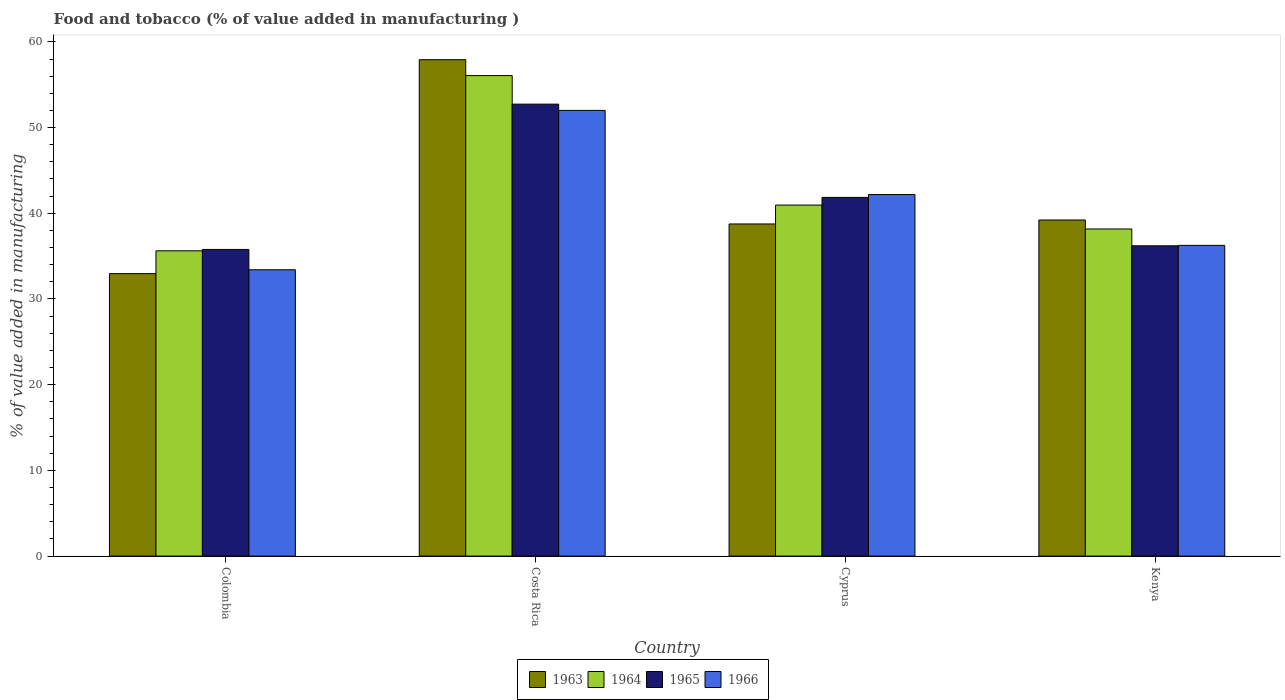Are the number of bars per tick equal to the number of legend labels?
Provide a short and direct response. Yes. How many bars are there on the 2nd tick from the left?
Ensure brevity in your answer.  4. How many bars are there on the 1st tick from the right?
Ensure brevity in your answer.  4. What is the label of the 3rd group of bars from the left?
Your response must be concise. Cyprus. What is the value added in manufacturing food and tobacco in 1966 in Cyprus?
Keep it short and to the point. 42.19. Across all countries, what is the maximum value added in manufacturing food and tobacco in 1965?
Offer a very short reply. 52.73. Across all countries, what is the minimum value added in manufacturing food and tobacco in 1964?
Make the answer very short. 35.62. In which country was the value added in manufacturing food and tobacco in 1965 minimum?
Offer a very short reply. Colombia. What is the total value added in manufacturing food and tobacco in 1965 in the graph?
Your response must be concise. 166.57. What is the difference between the value added in manufacturing food and tobacco in 1963 in Costa Rica and that in Kenya?
Your response must be concise. 18.7. What is the difference between the value added in manufacturing food and tobacco in 1966 in Costa Rica and the value added in manufacturing food and tobacco in 1964 in Colombia?
Ensure brevity in your answer.  16.38. What is the average value added in manufacturing food and tobacco in 1964 per country?
Offer a very short reply. 42.7. What is the difference between the value added in manufacturing food and tobacco of/in 1966 and value added in manufacturing food and tobacco of/in 1963 in Kenya?
Provide a short and direct response. -2.96. What is the ratio of the value added in manufacturing food and tobacco in 1965 in Costa Rica to that in Kenya?
Your response must be concise. 1.46. Is the value added in manufacturing food and tobacco in 1963 in Costa Rica less than that in Cyprus?
Provide a succinct answer. No. What is the difference between the highest and the second highest value added in manufacturing food and tobacco in 1966?
Provide a short and direct response. -9.82. What is the difference between the highest and the lowest value added in manufacturing food and tobacco in 1966?
Your answer should be compact. 18.59. In how many countries, is the value added in manufacturing food and tobacco in 1966 greater than the average value added in manufacturing food and tobacco in 1966 taken over all countries?
Your response must be concise. 2. Is the sum of the value added in manufacturing food and tobacco in 1964 in Colombia and Kenya greater than the maximum value added in manufacturing food and tobacco in 1965 across all countries?
Your response must be concise. Yes. Is it the case that in every country, the sum of the value added in manufacturing food and tobacco in 1966 and value added in manufacturing food and tobacco in 1964 is greater than the sum of value added in manufacturing food and tobacco in 1965 and value added in manufacturing food and tobacco in 1963?
Your answer should be very brief. No. What does the 3rd bar from the left in Cyprus represents?
Your answer should be compact. 1965. What does the 1st bar from the right in Costa Rica represents?
Your response must be concise. 1966. Is it the case that in every country, the sum of the value added in manufacturing food and tobacco in 1963 and value added in manufacturing food and tobacco in 1966 is greater than the value added in manufacturing food and tobacco in 1964?
Offer a very short reply. Yes. How many bars are there?
Give a very brief answer. 16. How many countries are there in the graph?
Your response must be concise. 4. How are the legend labels stacked?
Keep it short and to the point. Horizontal. What is the title of the graph?
Ensure brevity in your answer.  Food and tobacco (% of value added in manufacturing ). Does "1993" appear as one of the legend labels in the graph?
Ensure brevity in your answer.  No. What is the label or title of the X-axis?
Give a very brief answer. Country. What is the label or title of the Y-axis?
Offer a very short reply. % of value added in manufacturing. What is the % of value added in manufacturing of 1963 in Colombia?
Keep it short and to the point. 32.96. What is the % of value added in manufacturing of 1964 in Colombia?
Give a very brief answer. 35.62. What is the % of value added in manufacturing in 1965 in Colombia?
Your response must be concise. 35.78. What is the % of value added in manufacturing of 1966 in Colombia?
Ensure brevity in your answer.  33.41. What is the % of value added in manufacturing of 1963 in Costa Rica?
Your response must be concise. 57.92. What is the % of value added in manufacturing of 1964 in Costa Rica?
Provide a short and direct response. 56.07. What is the % of value added in manufacturing in 1965 in Costa Rica?
Your answer should be very brief. 52.73. What is the % of value added in manufacturing in 1966 in Costa Rica?
Offer a very short reply. 52. What is the % of value added in manufacturing in 1963 in Cyprus?
Your answer should be compact. 38.75. What is the % of value added in manufacturing in 1964 in Cyprus?
Your answer should be compact. 40.96. What is the % of value added in manufacturing of 1965 in Cyprus?
Offer a very short reply. 41.85. What is the % of value added in manufacturing of 1966 in Cyprus?
Give a very brief answer. 42.19. What is the % of value added in manufacturing of 1963 in Kenya?
Make the answer very short. 39.22. What is the % of value added in manufacturing in 1964 in Kenya?
Make the answer very short. 38.17. What is the % of value added in manufacturing in 1965 in Kenya?
Your response must be concise. 36.2. What is the % of value added in manufacturing in 1966 in Kenya?
Make the answer very short. 36.25. Across all countries, what is the maximum % of value added in manufacturing of 1963?
Make the answer very short. 57.92. Across all countries, what is the maximum % of value added in manufacturing of 1964?
Provide a succinct answer. 56.07. Across all countries, what is the maximum % of value added in manufacturing of 1965?
Offer a terse response. 52.73. Across all countries, what is the maximum % of value added in manufacturing of 1966?
Provide a short and direct response. 52. Across all countries, what is the minimum % of value added in manufacturing of 1963?
Ensure brevity in your answer.  32.96. Across all countries, what is the minimum % of value added in manufacturing of 1964?
Offer a very short reply. 35.62. Across all countries, what is the minimum % of value added in manufacturing of 1965?
Your answer should be compact. 35.78. Across all countries, what is the minimum % of value added in manufacturing of 1966?
Give a very brief answer. 33.41. What is the total % of value added in manufacturing of 1963 in the graph?
Give a very brief answer. 168.85. What is the total % of value added in manufacturing of 1964 in the graph?
Make the answer very short. 170.81. What is the total % of value added in manufacturing in 1965 in the graph?
Provide a short and direct response. 166.57. What is the total % of value added in manufacturing in 1966 in the graph?
Provide a succinct answer. 163.86. What is the difference between the % of value added in manufacturing in 1963 in Colombia and that in Costa Rica?
Your answer should be compact. -24.96. What is the difference between the % of value added in manufacturing in 1964 in Colombia and that in Costa Rica?
Your response must be concise. -20.45. What is the difference between the % of value added in manufacturing in 1965 in Colombia and that in Costa Rica?
Offer a terse response. -16.95. What is the difference between the % of value added in manufacturing in 1966 in Colombia and that in Costa Rica?
Provide a succinct answer. -18.59. What is the difference between the % of value added in manufacturing in 1963 in Colombia and that in Cyprus?
Provide a succinct answer. -5.79. What is the difference between the % of value added in manufacturing in 1964 in Colombia and that in Cyprus?
Your answer should be compact. -5.34. What is the difference between the % of value added in manufacturing of 1965 in Colombia and that in Cyprus?
Keep it short and to the point. -6.07. What is the difference between the % of value added in manufacturing of 1966 in Colombia and that in Cyprus?
Keep it short and to the point. -8.78. What is the difference between the % of value added in manufacturing in 1963 in Colombia and that in Kenya?
Make the answer very short. -6.26. What is the difference between the % of value added in manufacturing of 1964 in Colombia and that in Kenya?
Provide a short and direct response. -2.55. What is the difference between the % of value added in manufacturing in 1965 in Colombia and that in Kenya?
Keep it short and to the point. -0.42. What is the difference between the % of value added in manufacturing in 1966 in Colombia and that in Kenya?
Ensure brevity in your answer.  -2.84. What is the difference between the % of value added in manufacturing of 1963 in Costa Rica and that in Cyprus?
Make the answer very short. 19.17. What is the difference between the % of value added in manufacturing in 1964 in Costa Rica and that in Cyprus?
Provide a short and direct response. 15.11. What is the difference between the % of value added in manufacturing in 1965 in Costa Rica and that in Cyprus?
Ensure brevity in your answer.  10.88. What is the difference between the % of value added in manufacturing in 1966 in Costa Rica and that in Cyprus?
Your answer should be compact. 9.82. What is the difference between the % of value added in manufacturing in 1963 in Costa Rica and that in Kenya?
Offer a terse response. 18.7. What is the difference between the % of value added in manufacturing of 1964 in Costa Rica and that in Kenya?
Make the answer very short. 17.9. What is the difference between the % of value added in manufacturing in 1965 in Costa Rica and that in Kenya?
Your answer should be compact. 16.53. What is the difference between the % of value added in manufacturing in 1966 in Costa Rica and that in Kenya?
Make the answer very short. 15.75. What is the difference between the % of value added in manufacturing of 1963 in Cyprus and that in Kenya?
Provide a succinct answer. -0.46. What is the difference between the % of value added in manufacturing in 1964 in Cyprus and that in Kenya?
Give a very brief answer. 2.79. What is the difference between the % of value added in manufacturing of 1965 in Cyprus and that in Kenya?
Offer a terse response. 5.65. What is the difference between the % of value added in manufacturing of 1966 in Cyprus and that in Kenya?
Your answer should be compact. 5.93. What is the difference between the % of value added in manufacturing in 1963 in Colombia and the % of value added in manufacturing in 1964 in Costa Rica?
Make the answer very short. -23.11. What is the difference between the % of value added in manufacturing in 1963 in Colombia and the % of value added in manufacturing in 1965 in Costa Rica?
Ensure brevity in your answer.  -19.77. What is the difference between the % of value added in manufacturing in 1963 in Colombia and the % of value added in manufacturing in 1966 in Costa Rica?
Keep it short and to the point. -19.04. What is the difference between the % of value added in manufacturing of 1964 in Colombia and the % of value added in manufacturing of 1965 in Costa Rica?
Your answer should be compact. -17.11. What is the difference between the % of value added in manufacturing in 1964 in Colombia and the % of value added in manufacturing in 1966 in Costa Rica?
Offer a terse response. -16.38. What is the difference between the % of value added in manufacturing in 1965 in Colombia and the % of value added in manufacturing in 1966 in Costa Rica?
Offer a very short reply. -16.22. What is the difference between the % of value added in manufacturing of 1963 in Colombia and the % of value added in manufacturing of 1964 in Cyprus?
Your answer should be very brief. -8. What is the difference between the % of value added in manufacturing of 1963 in Colombia and the % of value added in manufacturing of 1965 in Cyprus?
Give a very brief answer. -8.89. What is the difference between the % of value added in manufacturing of 1963 in Colombia and the % of value added in manufacturing of 1966 in Cyprus?
Provide a short and direct response. -9.23. What is the difference between the % of value added in manufacturing of 1964 in Colombia and the % of value added in manufacturing of 1965 in Cyprus?
Your response must be concise. -6.23. What is the difference between the % of value added in manufacturing of 1964 in Colombia and the % of value added in manufacturing of 1966 in Cyprus?
Offer a terse response. -6.57. What is the difference between the % of value added in manufacturing of 1965 in Colombia and the % of value added in manufacturing of 1966 in Cyprus?
Your answer should be very brief. -6.41. What is the difference between the % of value added in manufacturing in 1963 in Colombia and the % of value added in manufacturing in 1964 in Kenya?
Your answer should be very brief. -5.21. What is the difference between the % of value added in manufacturing in 1963 in Colombia and the % of value added in manufacturing in 1965 in Kenya?
Provide a succinct answer. -3.24. What is the difference between the % of value added in manufacturing in 1963 in Colombia and the % of value added in manufacturing in 1966 in Kenya?
Keep it short and to the point. -3.29. What is the difference between the % of value added in manufacturing of 1964 in Colombia and the % of value added in manufacturing of 1965 in Kenya?
Offer a terse response. -0.58. What is the difference between the % of value added in manufacturing in 1964 in Colombia and the % of value added in manufacturing in 1966 in Kenya?
Your response must be concise. -0.63. What is the difference between the % of value added in manufacturing of 1965 in Colombia and the % of value added in manufacturing of 1966 in Kenya?
Ensure brevity in your answer.  -0.47. What is the difference between the % of value added in manufacturing in 1963 in Costa Rica and the % of value added in manufacturing in 1964 in Cyprus?
Your response must be concise. 16.96. What is the difference between the % of value added in manufacturing of 1963 in Costa Rica and the % of value added in manufacturing of 1965 in Cyprus?
Keep it short and to the point. 16.07. What is the difference between the % of value added in manufacturing of 1963 in Costa Rica and the % of value added in manufacturing of 1966 in Cyprus?
Offer a very short reply. 15.73. What is the difference between the % of value added in manufacturing in 1964 in Costa Rica and the % of value added in manufacturing in 1965 in Cyprus?
Give a very brief answer. 14.21. What is the difference between the % of value added in manufacturing of 1964 in Costa Rica and the % of value added in manufacturing of 1966 in Cyprus?
Give a very brief answer. 13.88. What is the difference between the % of value added in manufacturing of 1965 in Costa Rica and the % of value added in manufacturing of 1966 in Cyprus?
Keep it short and to the point. 10.55. What is the difference between the % of value added in manufacturing in 1963 in Costa Rica and the % of value added in manufacturing in 1964 in Kenya?
Offer a terse response. 19.75. What is the difference between the % of value added in manufacturing in 1963 in Costa Rica and the % of value added in manufacturing in 1965 in Kenya?
Offer a very short reply. 21.72. What is the difference between the % of value added in manufacturing in 1963 in Costa Rica and the % of value added in manufacturing in 1966 in Kenya?
Your answer should be very brief. 21.67. What is the difference between the % of value added in manufacturing in 1964 in Costa Rica and the % of value added in manufacturing in 1965 in Kenya?
Offer a terse response. 19.86. What is the difference between the % of value added in manufacturing in 1964 in Costa Rica and the % of value added in manufacturing in 1966 in Kenya?
Your answer should be very brief. 19.81. What is the difference between the % of value added in manufacturing in 1965 in Costa Rica and the % of value added in manufacturing in 1966 in Kenya?
Your answer should be compact. 16.48. What is the difference between the % of value added in manufacturing of 1963 in Cyprus and the % of value added in manufacturing of 1964 in Kenya?
Your response must be concise. 0.59. What is the difference between the % of value added in manufacturing in 1963 in Cyprus and the % of value added in manufacturing in 1965 in Kenya?
Provide a short and direct response. 2.55. What is the difference between the % of value added in manufacturing in 1963 in Cyprus and the % of value added in manufacturing in 1966 in Kenya?
Keep it short and to the point. 2.5. What is the difference between the % of value added in manufacturing in 1964 in Cyprus and the % of value added in manufacturing in 1965 in Kenya?
Provide a short and direct response. 4.75. What is the difference between the % of value added in manufacturing of 1964 in Cyprus and the % of value added in manufacturing of 1966 in Kenya?
Give a very brief answer. 4.7. What is the difference between the % of value added in manufacturing of 1965 in Cyprus and the % of value added in manufacturing of 1966 in Kenya?
Make the answer very short. 5.6. What is the average % of value added in manufacturing in 1963 per country?
Your answer should be compact. 42.21. What is the average % of value added in manufacturing in 1964 per country?
Your answer should be very brief. 42.7. What is the average % of value added in manufacturing in 1965 per country?
Your answer should be compact. 41.64. What is the average % of value added in manufacturing in 1966 per country?
Make the answer very short. 40.96. What is the difference between the % of value added in manufacturing of 1963 and % of value added in manufacturing of 1964 in Colombia?
Your response must be concise. -2.66. What is the difference between the % of value added in manufacturing of 1963 and % of value added in manufacturing of 1965 in Colombia?
Provide a short and direct response. -2.82. What is the difference between the % of value added in manufacturing in 1963 and % of value added in manufacturing in 1966 in Colombia?
Provide a short and direct response. -0.45. What is the difference between the % of value added in manufacturing of 1964 and % of value added in manufacturing of 1965 in Colombia?
Your answer should be compact. -0.16. What is the difference between the % of value added in manufacturing in 1964 and % of value added in manufacturing in 1966 in Colombia?
Offer a terse response. 2.21. What is the difference between the % of value added in manufacturing in 1965 and % of value added in manufacturing in 1966 in Colombia?
Give a very brief answer. 2.37. What is the difference between the % of value added in manufacturing of 1963 and % of value added in manufacturing of 1964 in Costa Rica?
Your response must be concise. 1.85. What is the difference between the % of value added in manufacturing in 1963 and % of value added in manufacturing in 1965 in Costa Rica?
Give a very brief answer. 5.19. What is the difference between the % of value added in manufacturing of 1963 and % of value added in manufacturing of 1966 in Costa Rica?
Provide a short and direct response. 5.92. What is the difference between the % of value added in manufacturing in 1964 and % of value added in manufacturing in 1965 in Costa Rica?
Your answer should be very brief. 3.33. What is the difference between the % of value added in manufacturing of 1964 and % of value added in manufacturing of 1966 in Costa Rica?
Provide a short and direct response. 4.06. What is the difference between the % of value added in manufacturing of 1965 and % of value added in manufacturing of 1966 in Costa Rica?
Give a very brief answer. 0.73. What is the difference between the % of value added in manufacturing of 1963 and % of value added in manufacturing of 1964 in Cyprus?
Your answer should be very brief. -2.2. What is the difference between the % of value added in manufacturing in 1963 and % of value added in manufacturing in 1965 in Cyprus?
Your answer should be very brief. -3.1. What is the difference between the % of value added in manufacturing of 1963 and % of value added in manufacturing of 1966 in Cyprus?
Offer a very short reply. -3.43. What is the difference between the % of value added in manufacturing of 1964 and % of value added in manufacturing of 1965 in Cyprus?
Provide a succinct answer. -0.9. What is the difference between the % of value added in manufacturing in 1964 and % of value added in manufacturing in 1966 in Cyprus?
Offer a very short reply. -1.23. What is the difference between the % of value added in manufacturing of 1963 and % of value added in manufacturing of 1964 in Kenya?
Offer a very short reply. 1.05. What is the difference between the % of value added in manufacturing of 1963 and % of value added in manufacturing of 1965 in Kenya?
Keep it short and to the point. 3.01. What is the difference between the % of value added in manufacturing in 1963 and % of value added in manufacturing in 1966 in Kenya?
Make the answer very short. 2.96. What is the difference between the % of value added in manufacturing of 1964 and % of value added in manufacturing of 1965 in Kenya?
Provide a succinct answer. 1.96. What is the difference between the % of value added in manufacturing of 1964 and % of value added in manufacturing of 1966 in Kenya?
Your answer should be very brief. 1.91. What is the ratio of the % of value added in manufacturing of 1963 in Colombia to that in Costa Rica?
Offer a very short reply. 0.57. What is the ratio of the % of value added in manufacturing of 1964 in Colombia to that in Costa Rica?
Offer a very short reply. 0.64. What is the ratio of the % of value added in manufacturing of 1965 in Colombia to that in Costa Rica?
Make the answer very short. 0.68. What is the ratio of the % of value added in manufacturing of 1966 in Colombia to that in Costa Rica?
Offer a terse response. 0.64. What is the ratio of the % of value added in manufacturing of 1963 in Colombia to that in Cyprus?
Ensure brevity in your answer.  0.85. What is the ratio of the % of value added in manufacturing in 1964 in Colombia to that in Cyprus?
Your answer should be compact. 0.87. What is the ratio of the % of value added in manufacturing in 1965 in Colombia to that in Cyprus?
Your answer should be compact. 0.85. What is the ratio of the % of value added in manufacturing in 1966 in Colombia to that in Cyprus?
Your answer should be compact. 0.79. What is the ratio of the % of value added in manufacturing in 1963 in Colombia to that in Kenya?
Provide a short and direct response. 0.84. What is the ratio of the % of value added in manufacturing of 1964 in Colombia to that in Kenya?
Make the answer very short. 0.93. What is the ratio of the % of value added in manufacturing of 1965 in Colombia to that in Kenya?
Offer a terse response. 0.99. What is the ratio of the % of value added in manufacturing in 1966 in Colombia to that in Kenya?
Offer a very short reply. 0.92. What is the ratio of the % of value added in manufacturing in 1963 in Costa Rica to that in Cyprus?
Provide a short and direct response. 1.49. What is the ratio of the % of value added in manufacturing in 1964 in Costa Rica to that in Cyprus?
Provide a short and direct response. 1.37. What is the ratio of the % of value added in manufacturing of 1965 in Costa Rica to that in Cyprus?
Your answer should be compact. 1.26. What is the ratio of the % of value added in manufacturing in 1966 in Costa Rica to that in Cyprus?
Provide a succinct answer. 1.23. What is the ratio of the % of value added in manufacturing of 1963 in Costa Rica to that in Kenya?
Your answer should be compact. 1.48. What is the ratio of the % of value added in manufacturing of 1964 in Costa Rica to that in Kenya?
Provide a succinct answer. 1.47. What is the ratio of the % of value added in manufacturing in 1965 in Costa Rica to that in Kenya?
Your answer should be compact. 1.46. What is the ratio of the % of value added in manufacturing in 1966 in Costa Rica to that in Kenya?
Your answer should be very brief. 1.43. What is the ratio of the % of value added in manufacturing in 1964 in Cyprus to that in Kenya?
Ensure brevity in your answer.  1.07. What is the ratio of the % of value added in manufacturing in 1965 in Cyprus to that in Kenya?
Your answer should be compact. 1.16. What is the ratio of the % of value added in manufacturing in 1966 in Cyprus to that in Kenya?
Provide a succinct answer. 1.16. What is the difference between the highest and the second highest % of value added in manufacturing in 1963?
Make the answer very short. 18.7. What is the difference between the highest and the second highest % of value added in manufacturing of 1964?
Keep it short and to the point. 15.11. What is the difference between the highest and the second highest % of value added in manufacturing of 1965?
Your response must be concise. 10.88. What is the difference between the highest and the second highest % of value added in manufacturing of 1966?
Your response must be concise. 9.82. What is the difference between the highest and the lowest % of value added in manufacturing of 1963?
Offer a terse response. 24.96. What is the difference between the highest and the lowest % of value added in manufacturing of 1964?
Give a very brief answer. 20.45. What is the difference between the highest and the lowest % of value added in manufacturing in 1965?
Keep it short and to the point. 16.95. What is the difference between the highest and the lowest % of value added in manufacturing of 1966?
Ensure brevity in your answer.  18.59. 